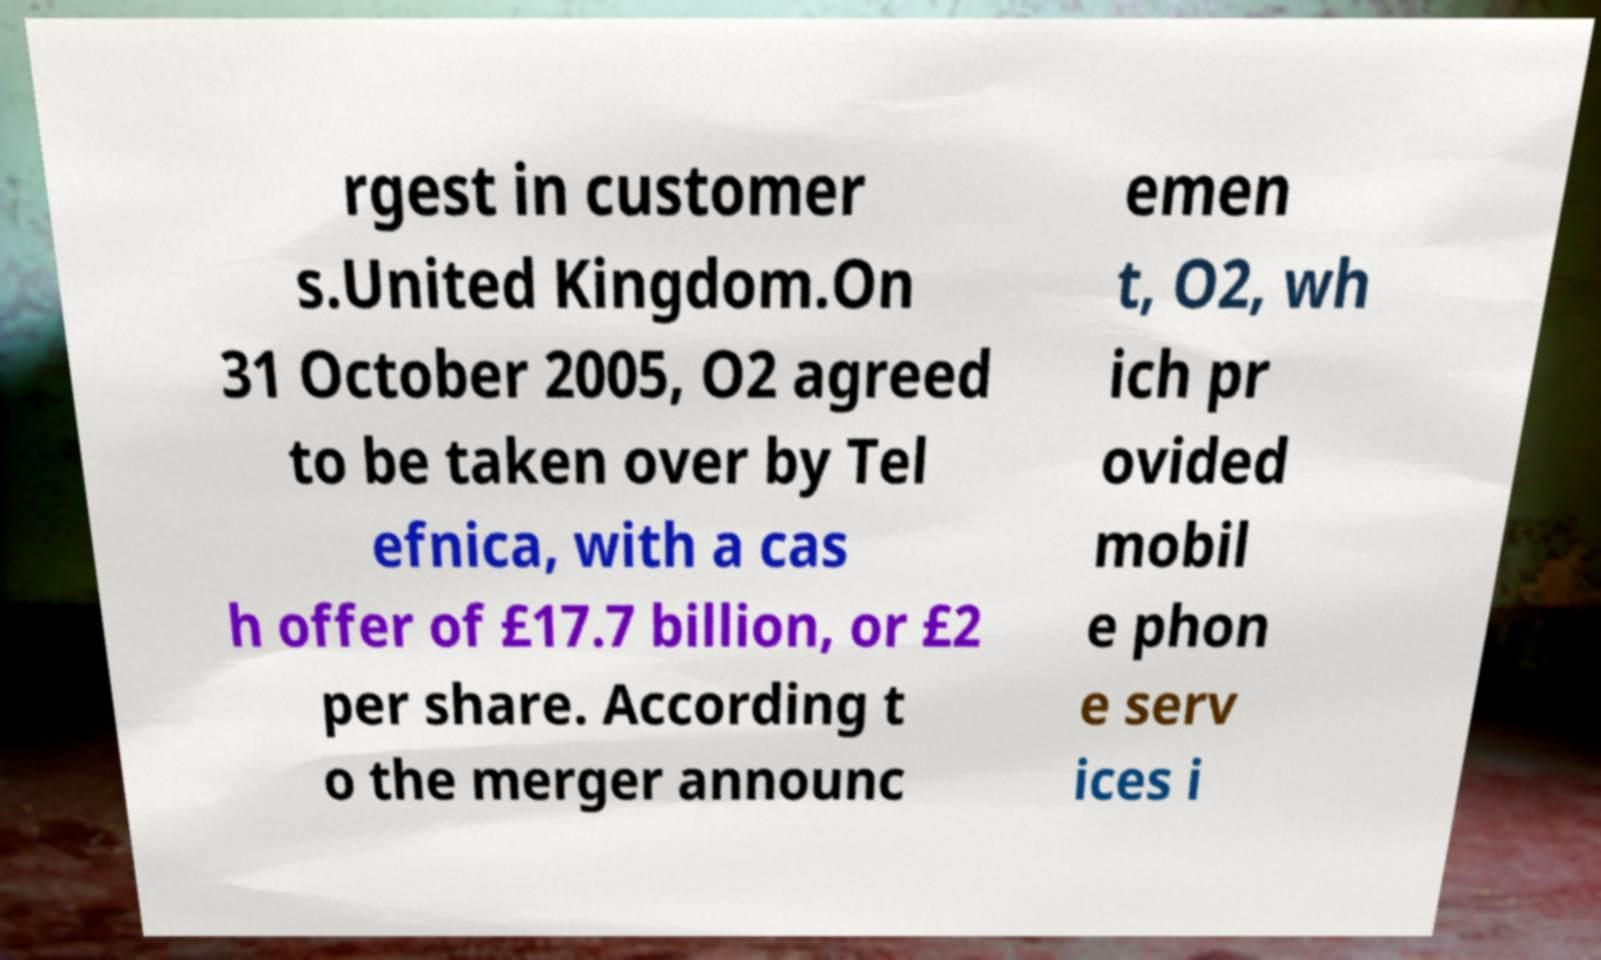Please identify and transcribe the text found in this image. rgest in customer s.United Kingdom.On 31 October 2005, O2 agreed to be taken over by Tel efnica, with a cas h offer of £17.7 billion, or £2 per share. According t o the merger announc emen t, O2, wh ich pr ovided mobil e phon e serv ices i 